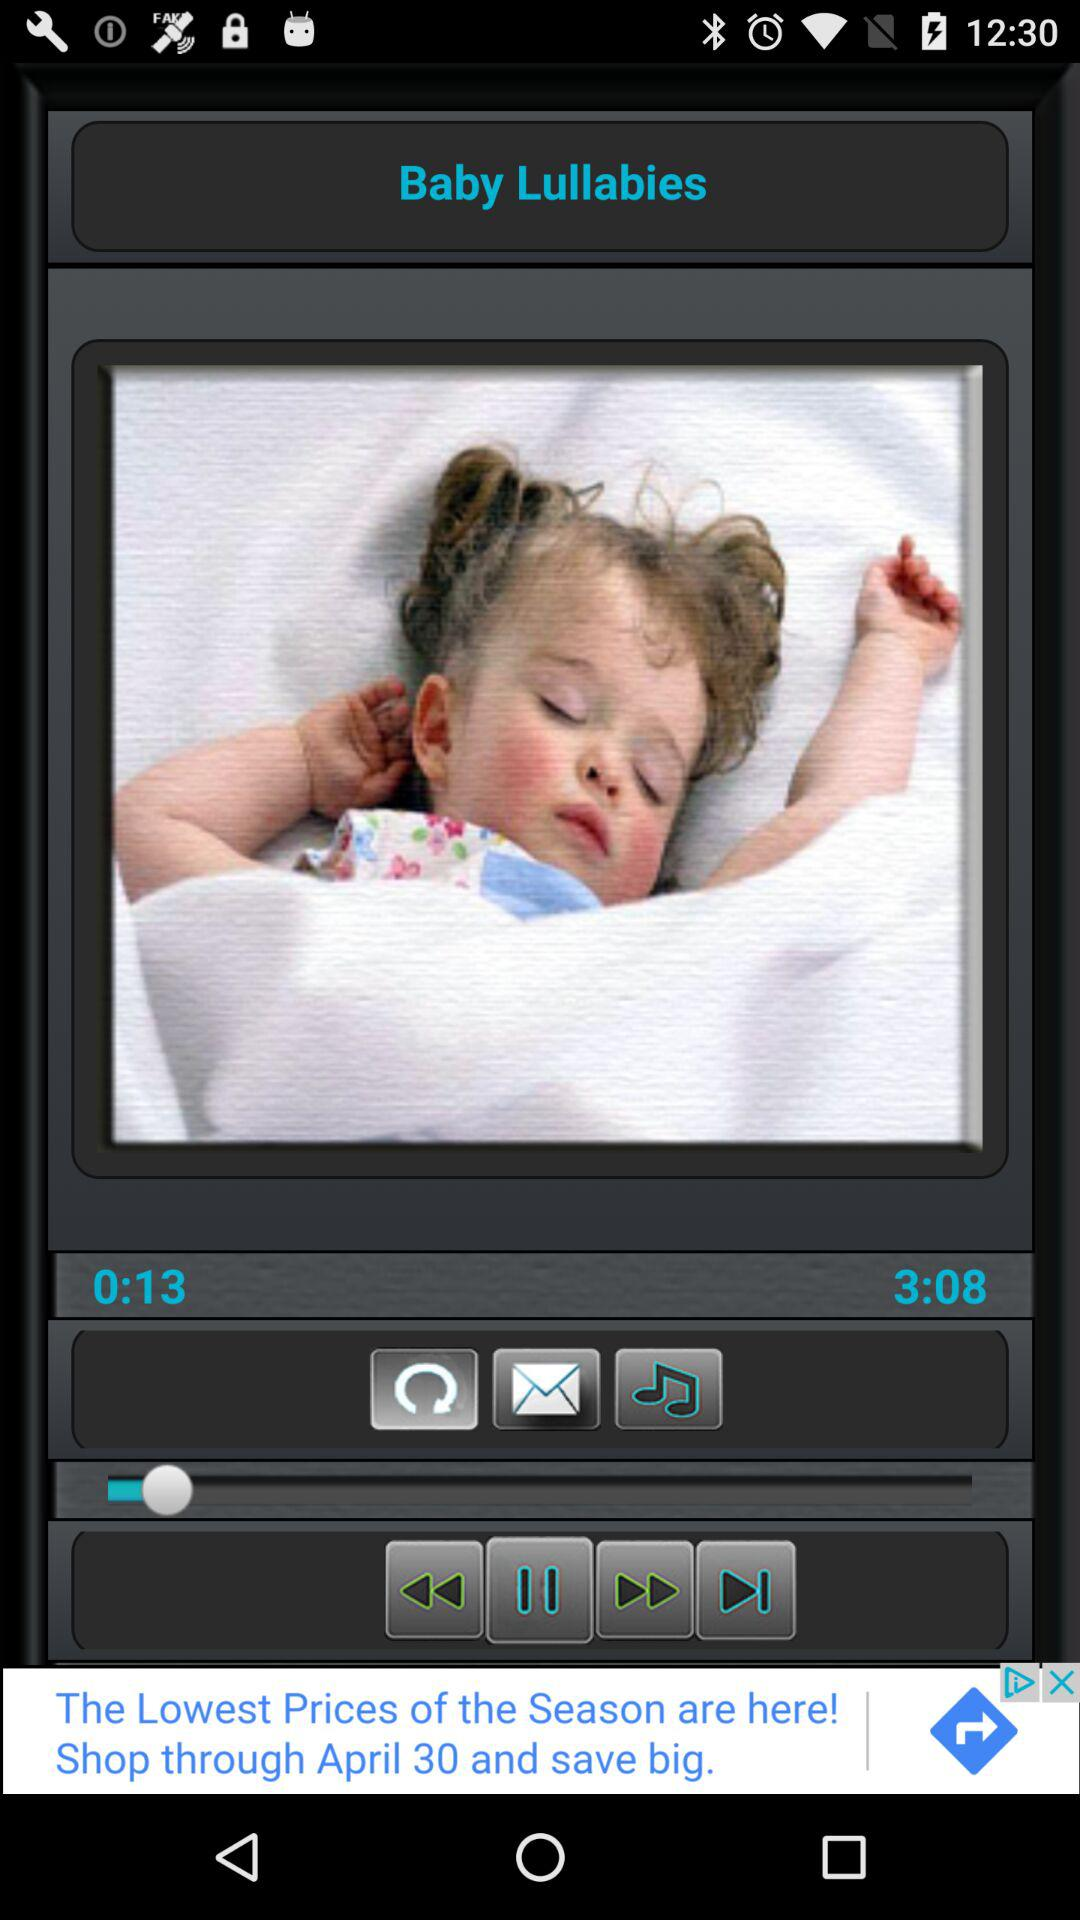What is the duration of the audio? The duration of the audio is 3 minutes 8 seconds. 